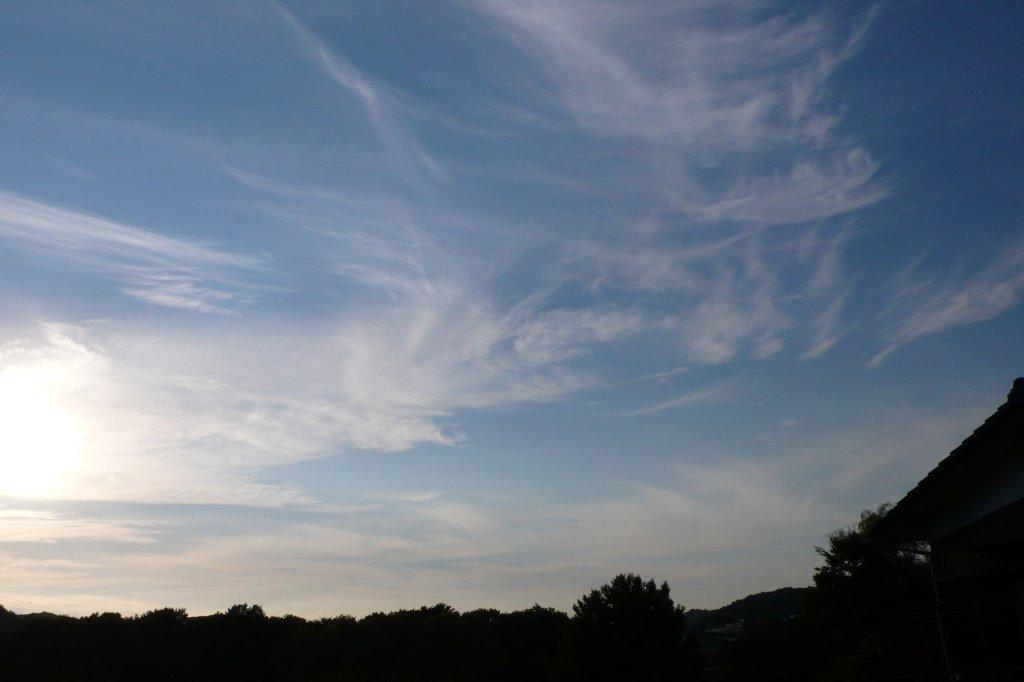What type of vegetation can be seen in the image? There are trees in the image. What is the condition of the sky in the image? The sky is cloudy in the image. Can you tell me how the earthquake affected the trees in the image? There is no earthquake present in the image, so its effects on the trees cannot be determined. What scientific discoveries are depicted in the image? There are no scientific discoveries depicted in the image; it features trees and a cloudy sky. 